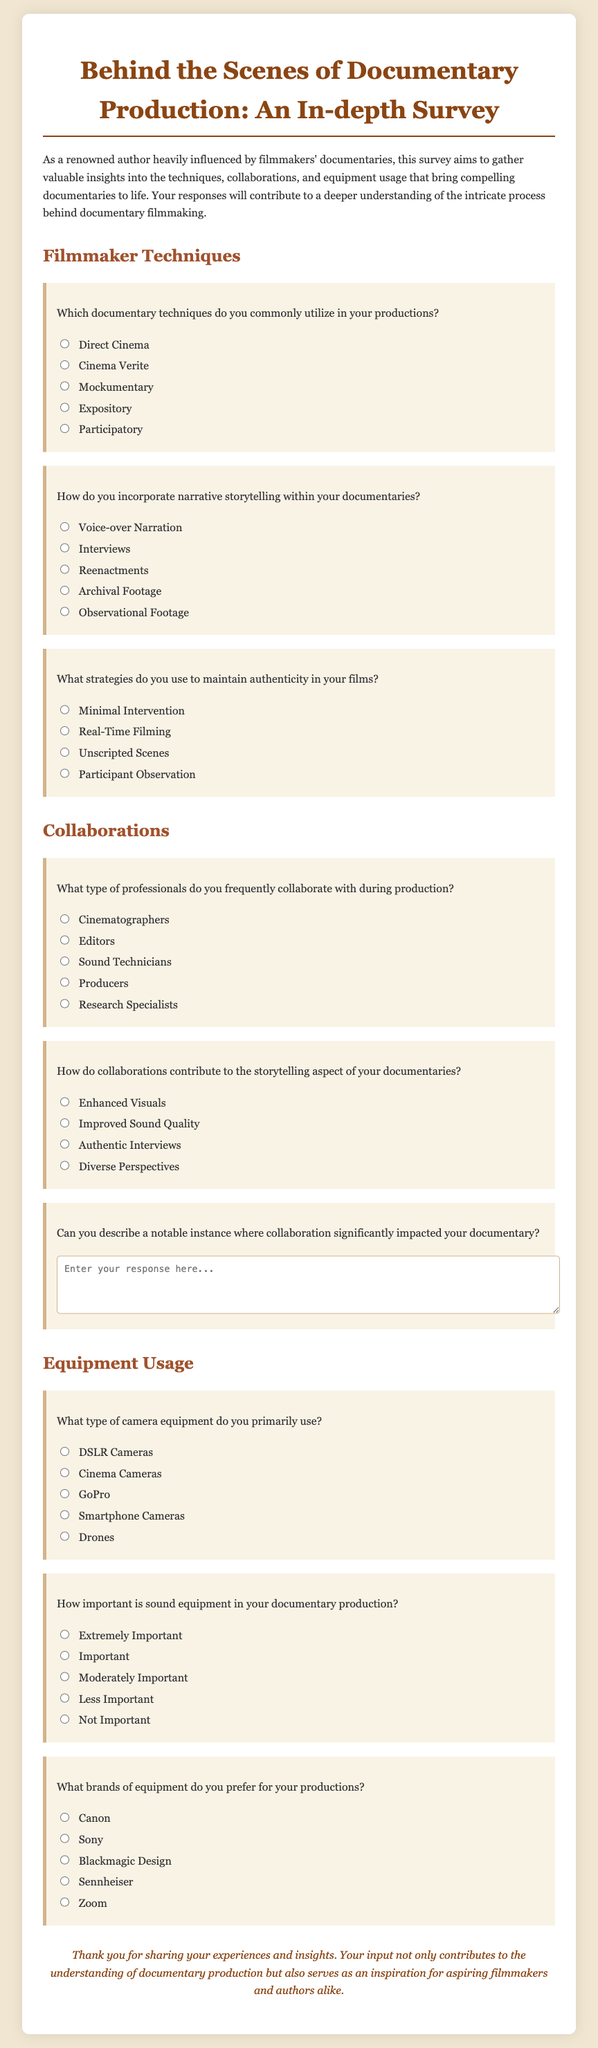What are the documentary techniques mentioned? The document lists several techniques utilized in documentary production.
Answer: Direct Cinema, Cinema Verite, Mockumentary, Expository, Participatory Which storytelling method uses archival footage? The document indicates that archival footage is a method used to incorporate narrative storytelling.
Answer: Archival Footage What professionals are commonly collaborated with? The document highlights the types of professionals frequently involved in documentary production.
Answer: Cinematographers, Editors, Sound Technicians, Producers, Research Specialists How do collaborations enhance storytelling? The document outlines the ways in which collaborations contribute to storytelling aspects.
Answer: Enhanced Visuals, Improved Sound Quality, Authentic Interviews, Diverse Perspectives What is the preferred camera equipment type used? The document specifies the types of camera equipment commonly used in production.
Answer: DSLR Cameras, Cinema Cameras, GoPro, Smartphone Cameras, Drones How important is sound equipment in the survey? The document provides a scale of importance for sound equipment in documentary production.
Answer: Extremely Important, Important, Moderately Important, Less Important, Not Important Which brand is mentioned for sound equipment? The document lists preferred brands for equipment used in documentary production.
Answer: Sennheiser, Zoom What type of filming is associated with authenticity? The document defines the strategies used to maintain authenticity in documentaries.
Answer: Real-Time Filming, Minimal Intervention, Unscripted Scenes, Participant Observation 